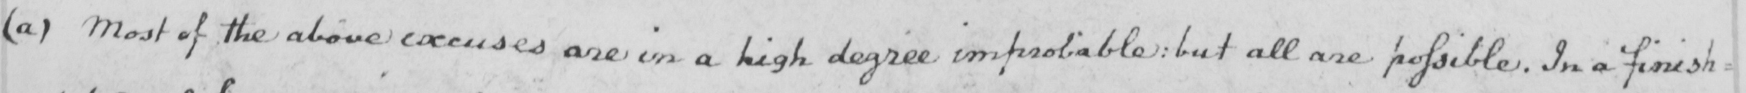What text is written in this handwritten line? ( a )  Most of the above excuses are in a high degree improbable :  but all are possible . In a finish= 